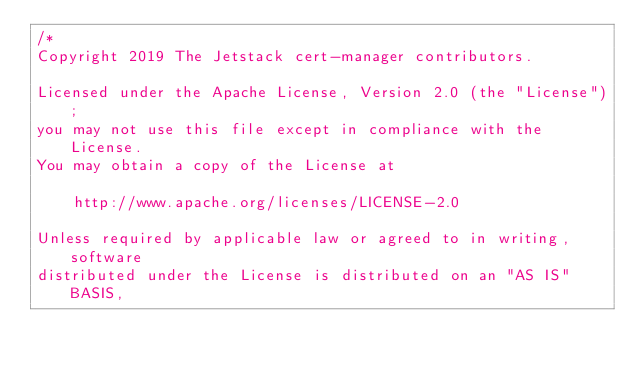Convert code to text. <code><loc_0><loc_0><loc_500><loc_500><_Go_>/*
Copyright 2019 The Jetstack cert-manager contributors.

Licensed under the Apache License, Version 2.0 (the "License");
you may not use this file except in compliance with the License.
You may obtain a copy of the License at

    http://www.apache.org/licenses/LICENSE-2.0

Unless required by applicable law or agreed to in writing, software
distributed under the License is distributed on an "AS IS" BASIS,</code> 